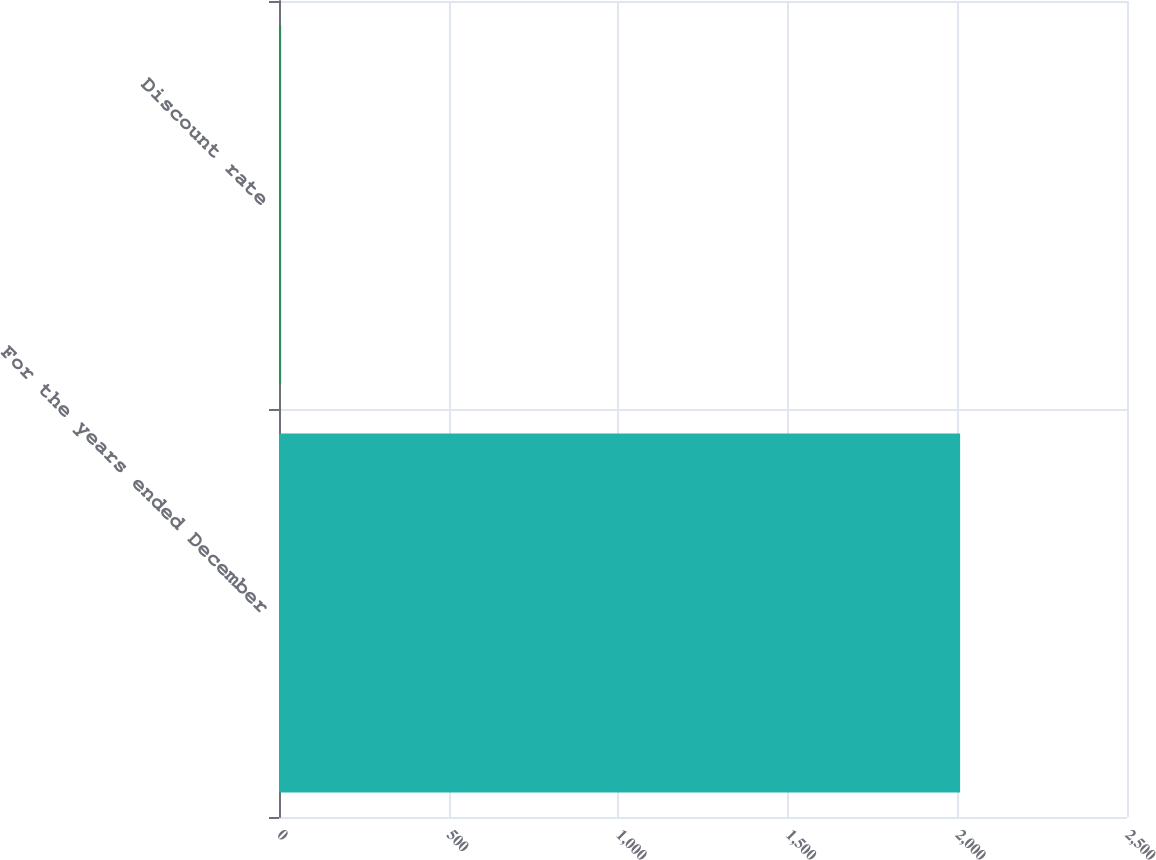Convert chart to OTSL. <chart><loc_0><loc_0><loc_500><loc_500><bar_chart><fcel>For the years ended December<fcel>Discount rate<nl><fcel>2008<fcel>6.3<nl></chart> 